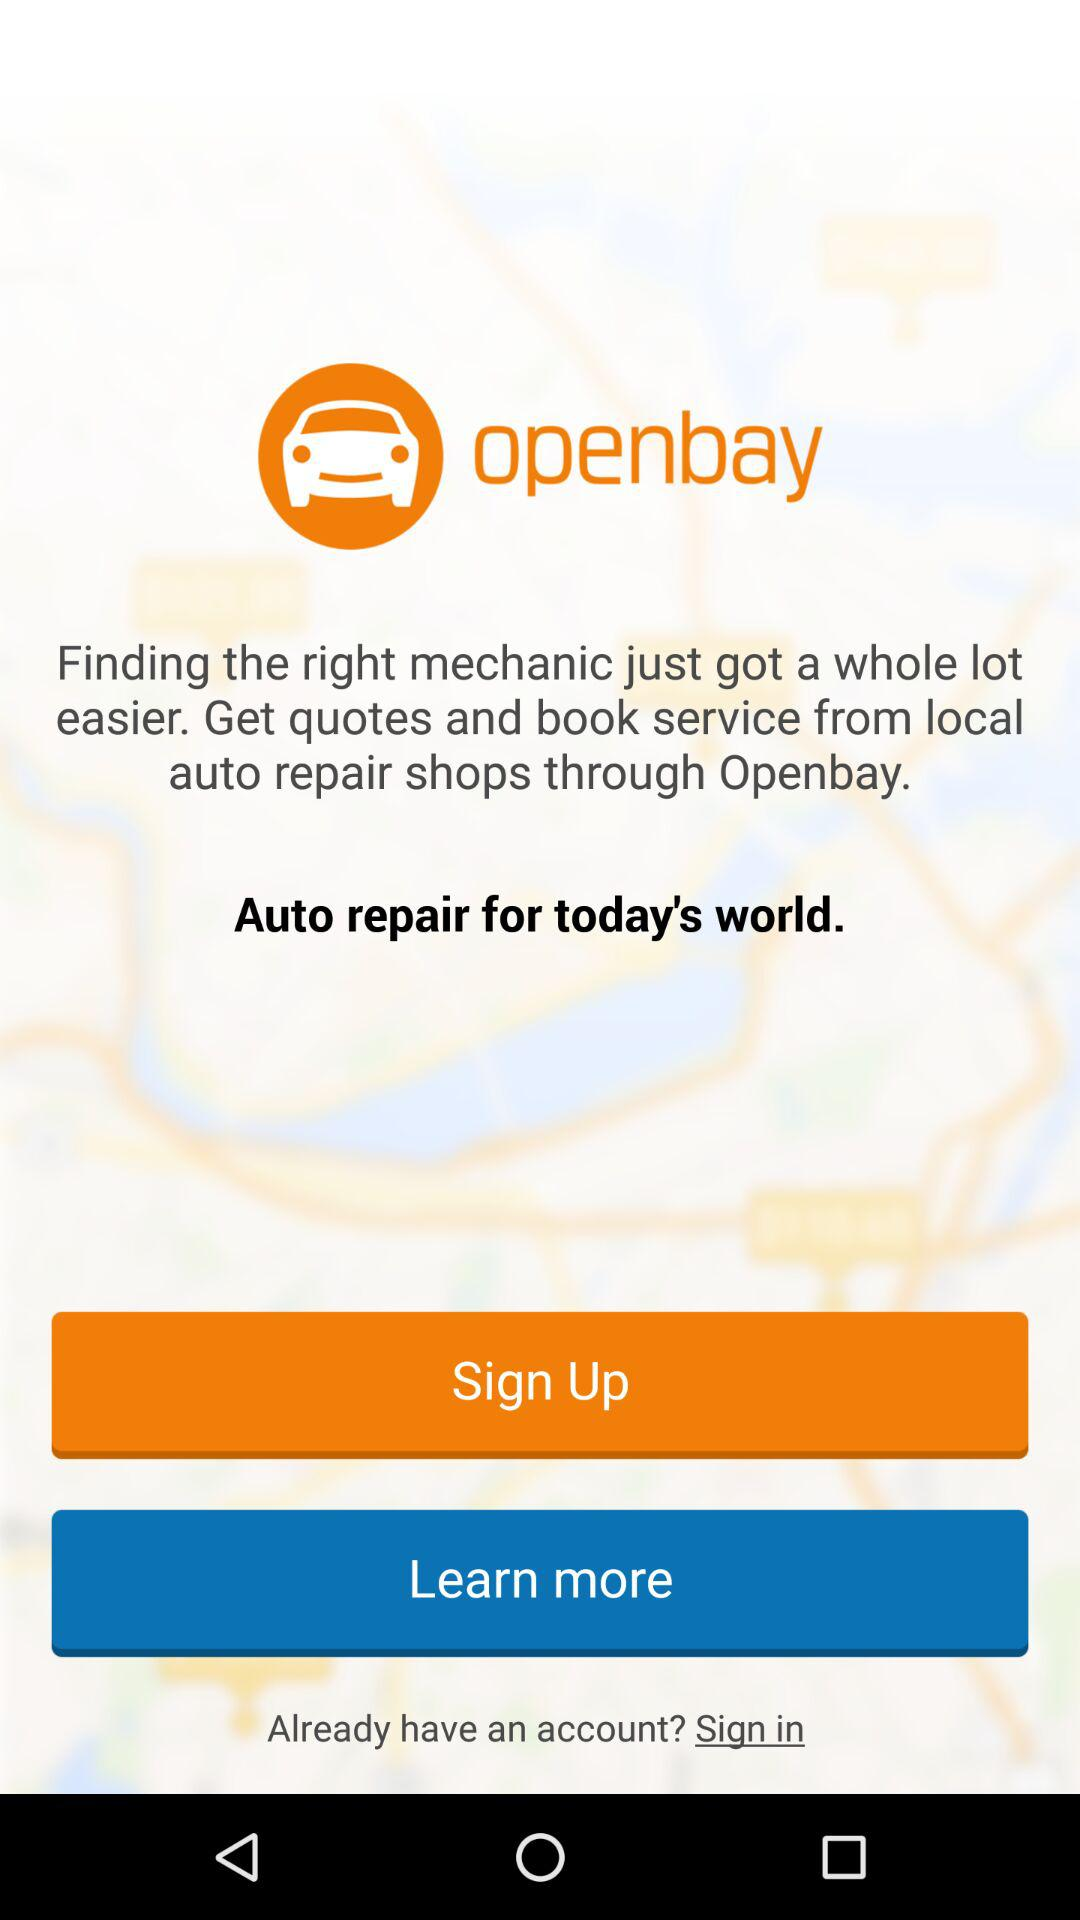What application is asking for a sign up? The application "openbay" is asking for a sign up. 